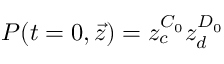Convert formula to latex. <formula><loc_0><loc_0><loc_500><loc_500>P ( t = 0 , \vec { z } ) = z _ { c } ^ { C _ { 0 } } z _ { d } ^ { D _ { 0 } }</formula> 